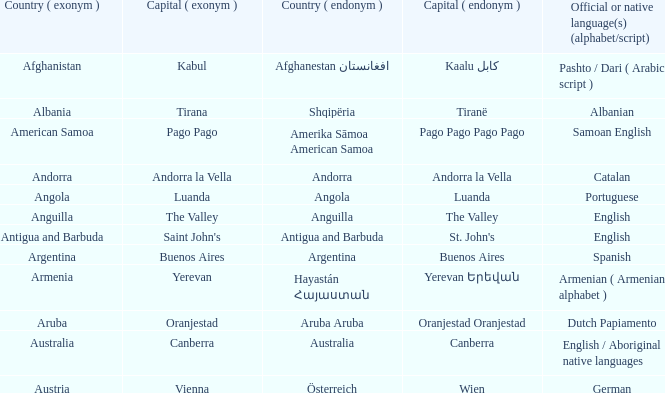What is the local name given to the capital of Anguilla? The Valley. 